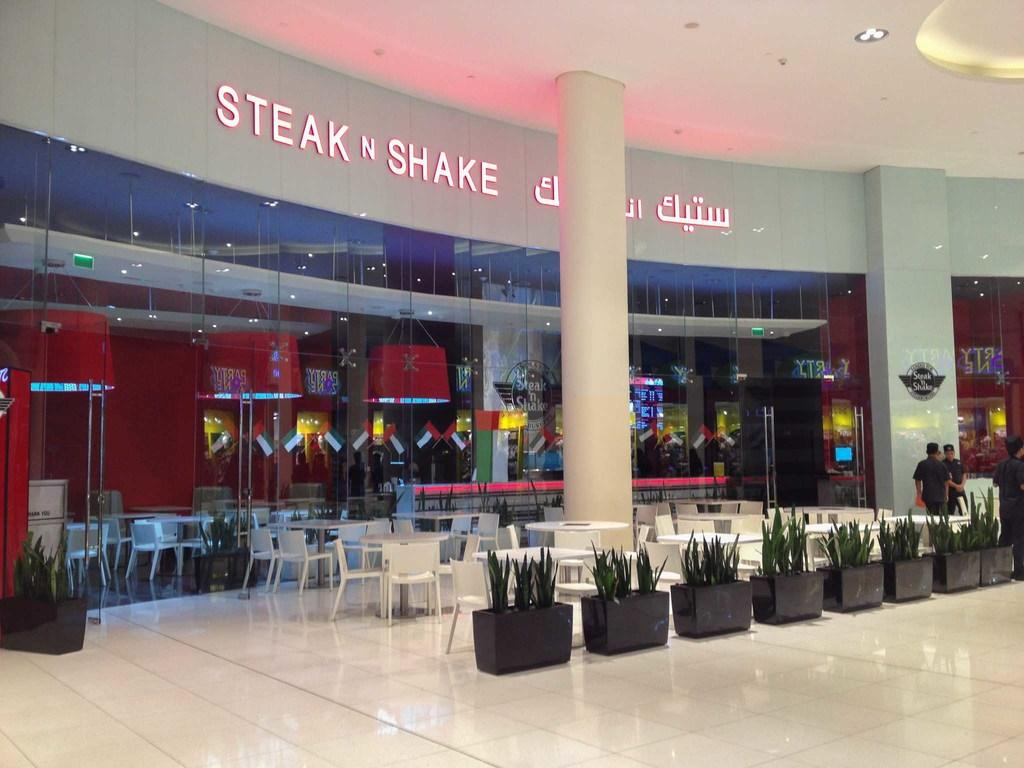<image>
Write a terse but informative summary of the picture. A Steak n Shake restaurant has a row of planters with cactus in them in front of the sotre 